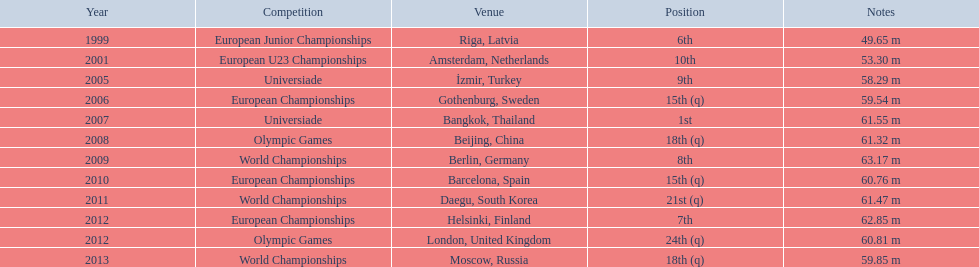Which competitions has gerhard mayer competed in since 1999? European Junior Championships, European U23 Championships, Universiade, European Championships, Universiade, Olympic Games, World Championships, European Championships, World Championships, European Championships, Olympic Games, World Championships. Of these competition, in which ones did he throw at least 60 m? Universiade, Olympic Games, World Championships, European Championships, World Championships, European Championships, Olympic Games. Of these throws, which was his longest? 63.17 m. 